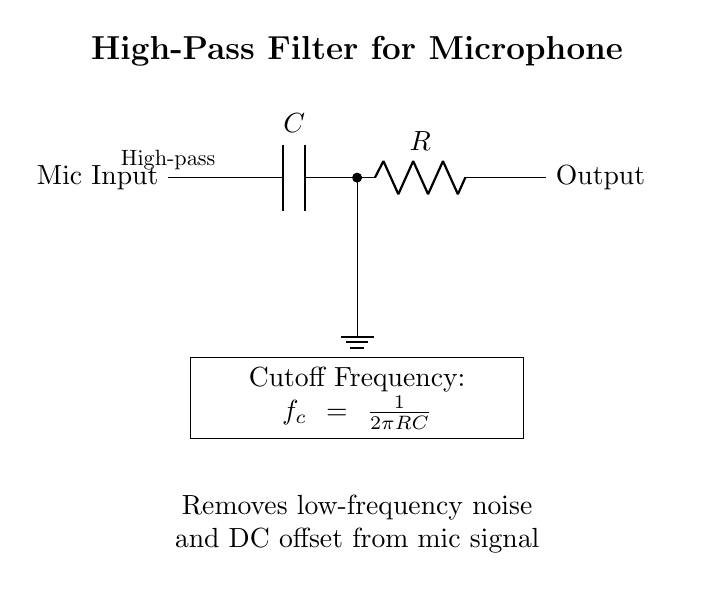What type of filter is shown in the circuit? The diagram clearly indicates that it is a "high-pass filter" as stated near the capacitor symbol, indicating its function to allow high-frequency signals to pass while attenuating low-frequency components.
Answer: high-pass filter What are the two main components of this circuit? The circuit consists of a capacitor and a resistor. The labels near the symbols clearly identify these components.
Answer: capacitor and resistor What is the purpose of the high-pass filter in this circuit? The explanation below the circuit states that the purpose is to "remove low-frequency noise and DC offset from mic signal," indicating its function in audio applications.
Answer: remove low-frequency noise What is the formula for cutoff frequency in this circuit? The formula for the cutoff frequency is provided in the circuit as f_c = 1/(2πRC). This relates the cutoff frequency to the values of the resistor and capacitor in the circuit.
Answer: f_c = 1/(2πRC) Which component connects to ground in this circuit? The schematic shows that the capacitor connects to ground, as denoted by the line going down to the ground symbol from the point connecting the capacitor and resistor.
Answer: capacitor What does the presence of the capacitor indicate about frequencies? The capacitor in the circuit allows high frequencies to pass while blocking low frequencies, which is characteristic of high-pass filter behavior, as described in the context.
Answer: allows high frequencies How does the resistor affect the high-pass filter circuit? The resistor, in combination with the capacitor, determines the cutoff frequency of the filter; altering the resistor value would change the cutoff frequency according to f_c = 1/(2πRC).
Answer: affects cutoff frequency 